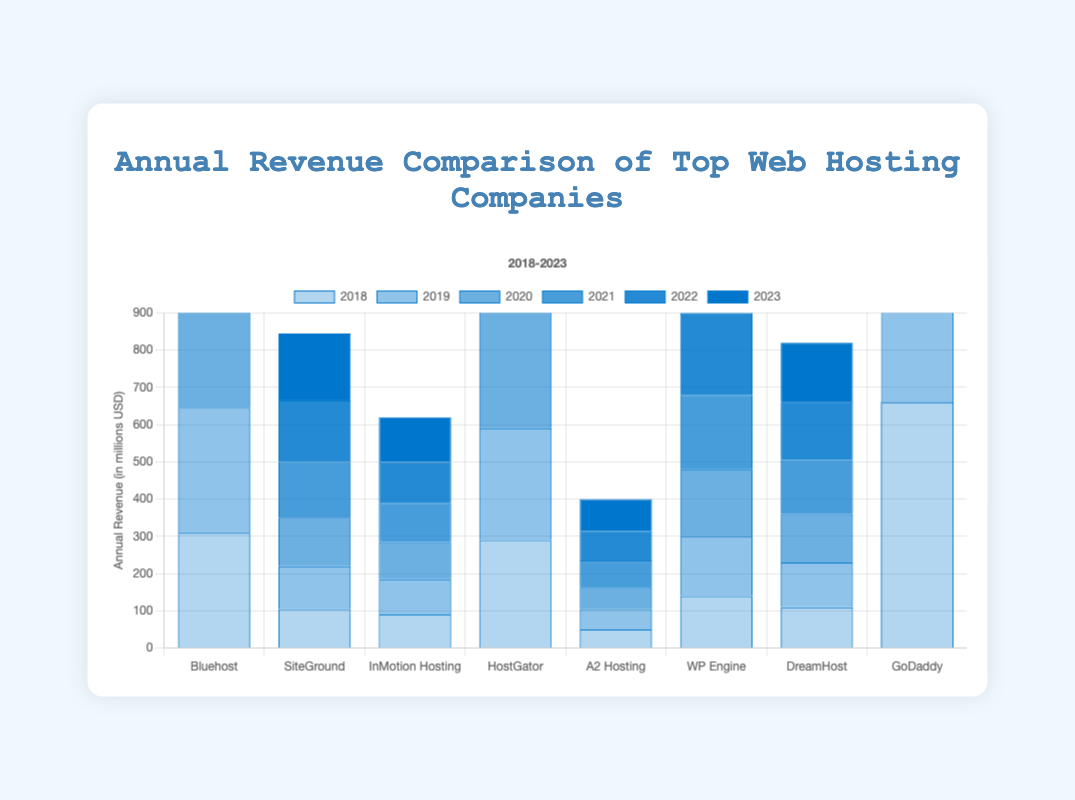How does the revenue of Bluehost in 2023 compare to its revenue in 2018? In 2018, Bluehost's revenue was $310 million, and in 2023, it increased to $410 million. The calculation involves finding the difference: $410 million - $310 million = $100 million increase
Answer: $100 million increase Which company had the highest revenue in 2023? By examining the heights of the bars for 2023, GoDaddy has the highest bar, indicating it has the highest revenue at $830 million
Answer: GoDaddy Identify the company with the lowest revenue growth from 2018 to 2023 To find this, calculate the difference between the revenues for each company over these years, and compare them. A2 Hosting grew from $50 million to $85 million, which is a $35 million increase. This is the smallest growth in comparison to the other companies
Answer: A2 Hosting What is the total revenue of SiteGround for the years 2021 and 2022 combined? Add the revenues for SiteGround for 2021 and 2022: $150 million + $165 million = $315 million
Answer: $315 million How many companies had a revenue over $400 million in 2023? In 2023, GoDaddy ($830 million) and Bluehost ($410 million) had revenues over $400 million. That's a total of 2 companies
Answer: 2 Compare the revenue difference between Bluehost and DreamHost in 2020 Bluehost's revenue in 2020 was $350 million, while DreamHost's revenue was $130 million. The difference: $350 million - $130 million = $220 million
Answer: $220 million Which company had a consistently increasing revenue every year from 2018 to 2023? By observing the bar heights for each company across the years, all listed companies (Bluehost, SiteGround, InMotion Hosting, HostGator, A2 Hosting, WP Engine, DreamHost, and GoDaddy) show a consistent increase in revenue every year
Answer: All listed companies Identify the average annual revenue of InMotion Hosting from 2018 to 2023 To find this, calculate the sum of InMotion Hosting's revenues over these years, and divide by the number of years: (90 + 95 + 100 + 105 + 110 + 120) / 6 = 103.33 million USD (rounded to two decimal places)
Answer: 103.33 million USD 